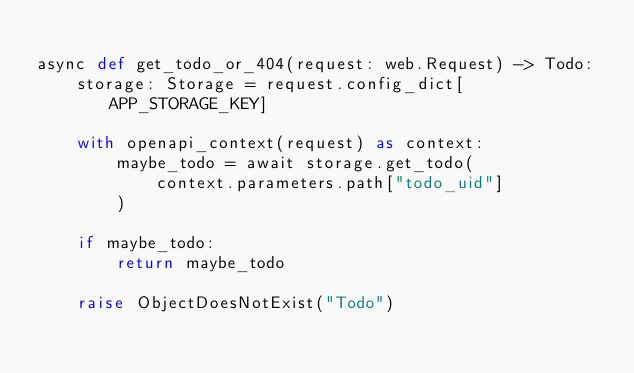<code> <loc_0><loc_0><loc_500><loc_500><_Python_>
async def get_todo_or_404(request: web.Request) -> Todo:
    storage: Storage = request.config_dict[APP_STORAGE_KEY]

    with openapi_context(request) as context:
        maybe_todo = await storage.get_todo(
            context.parameters.path["todo_uid"]
        )

    if maybe_todo:
        return maybe_todo

    raise ObjectDoesNotExist("Todo")
</code> 